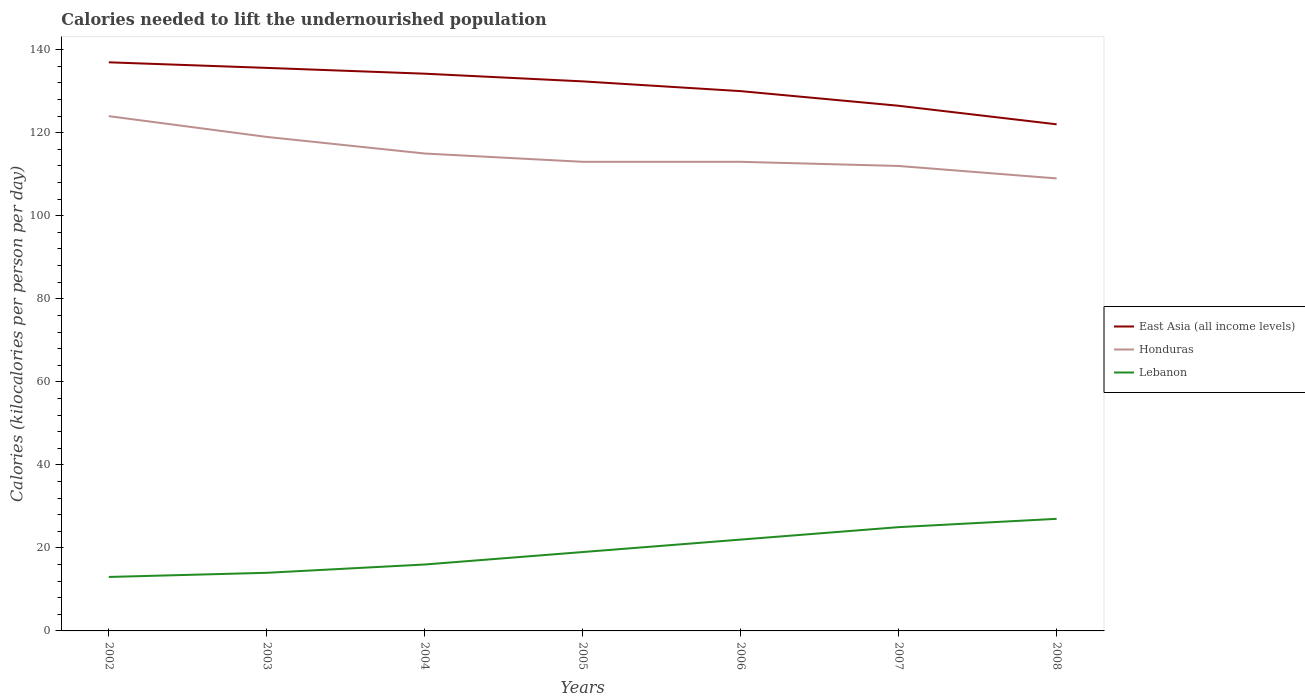Across all years, what is the maximum total calories needed to lift the undernourished population in East Asia (all income levels)?
Your answer should be compact. 122.04. In which year was the total calories needed to lift the undernourished population in Honduras maximum?
Ensure brevity in your answer.  2008. What is the total total calories needed to lift the undernourished population in Lebanon in the graph?
Your answer should be compact. -5. What is the difference between the highest and the second highest total calories needed to lift the undernourished population in Honduras?
Keep it short and to the point. 15. Is the total calories needed to lift the undernourished population in Lebanon strictly greater than the total calories needed to lift the undernourished population in East Asia (all income levels) over the years?
Your answer should be very brief. Yes. How many lines are there?
Offer a terse response. 3. Does the graph contain any zero values?
Your answer should be compact. No. Does the graph contain grids?
Keep it short and to the point. No. Where does the legend appear in the graph?
Give a very brief answer. Center right. How are the legend labels stacked?
Make the answer very short. Vertical. What is the title of the graph?
Offer a very short reply. Calories needed to lift the undernourished population. Does "Grenada" appear as one of the legend labels in the graph?
Make the answer very short. No. What is the label or title of the X-axis?
Your answer should be very brief. Years. What is the label or title of the Y-axis?
Your response must be concise. Calories (kilocalories per person per day). What is the Calories (kilocalories per person per day) in East Asia (all income levels) in 2002?
Offer a terse response. 136.97. What is the Calories (kilocalories per person per day) in Honduras in 2002?
Provide a succinct answer. 124. What is the Calories (kilocalories per person per day) in Lebanon in 2002?
Your response must be concise. 13. What is the Calories (kilocalories per person per day) of East Asia (all income levels) in 2003?
Keep it short and to the point. 135.63. What is the Calories (kilocalories per person per day) of Honduras in 2003?
Make the answer very short. 119. What is the Calories (kilocalories per person per day) of East Asia (all income levels) in 2004?
Offer a very short reply. 134.23. What is the Calories (kilocalories per person per day) of Honduras in 2004?
Your response must be concise. 115. What is the Calories (kilocalories per person per day) in Lebanon in 2004?
Make the answer very short. 16. What is the Calories (kilocalories per person per day) of East Asia (all income levels) in 2005?
Give a very brief answer. 132.38. What is the Calories (kilocalories per person per day) of Honduras in 2005?
Offer a terse response. 113. What is the Calories (kilocalories per person per day) of East Asia (all income levels) in 2006?
Ensure brevity in your answer.  130.03. What is the Calories (kilocalories per person per day) of Honduras in 2006?
Offer a terse response. 113. What is the Calories (kilocalories per person per day) in Lebanon in 2006?
Ensure brevity in your answer.  22. What is the Calories (kilocalories per person per day) in East Asia (all income levels) in 2007?
Offer a terse response. 126.5. What is the Calories (kilocalories per person per day) in Honduras in 2007?
Make the answer very short. 112. What is the Calories (kilocalories per person per day) in Lebanon in 2007?
Your answer should be compact. 25. What is the Calories (kilocalories per person per day) of East Asia (all income levels) in 2008?
Your answer should be very brief. 122.04. What is the Calories (kilocalories per person per day) in Honduras in 2008?
Your answer should be very brief. 109. Across all years, what is the maximum Calories (kilocalories per person per day) of East Asia (all income levels)?
Offer a very short reply. 136.97. Across all years, what is the maximum Calories (kilocalories per person per day) of Honduras?
Make the answer very short. 124. Across all years, what is the maximum Calories (kilocalories per person per day) of Lebanon?
Keep it short and to the point. 27. Across all years, what is the minimum Calories (kilocalories per person per day) in East Asia (all income levels)?
Your response must be concise. 122.04. Across all years, what is the minimum Calories (kilocalories per person per day) in Honduras?
Provide a succinct answer. 109. What is the total Calories (kilocalories per person per day) in East Asia (all income levels) in the graph?
Keep it short and to the point. 917.77. What is the total Calories (kilocalories per person per day) of Honduras in the graph?
Your answer should be compact. 805. What is the total Calories (kilocalories per person per day) in Lebanon in the graph?
Provide a short and direct response. 136. What is the difference between the Calories (kilocalories per person per day) in East Asia (all income levels) in 2002 and that in 2003?
Provide a succinct answer. 1.34. What is the difference between the Calories (kilocalories per person per day) of East Asia (all income levels) in 2002 and that in 2004?
Give a very brief answer. 2.74. What is the difference between the Calories (kilocalories per person per day) of East Asia (all income levels) in 2002 and that in 2005?
Your response must be concise. 4.59. What is the difference between the Calories (kilocalories per person per day) in Lebanon in 2002 and that in 2005?
Offer a terse response. -6. What is the difference between the Calories (kilocalories per person per day) of East Asia (all income levels) in 2002 and that in 2006?
Keep it short and to the point. 6.94. What is the difference between the Calories (kilocalories per person per day) of Honduras in 2002 and that in 2006?
Offer a very short reply. 11. What is the difference between the Calories (kilocalories per person per day) of East Asia (all income levels) in 2002 and that in 2007?
Your answer should be compact. 10.47. What is the difference between the Calories (kilocalories per person per day) of Honduras in 2002 and that in 2007?
Offer a very short reply. 12. What is the difference between the Calories (kilocalories per person per day) of East Asia (all income levels) in 2002 and that in 2008?
Provide a short and direct response. 14.94. What is the difference between the Calories (kilocalories per person per day) in Lebanon in 2002 and that in 2008?
Provide a short and direct response. -14. What is the difference between the Calories (kilocalories per person per day) in East Asia (all income levels) in 2003 and that in 2004?
Provide a short and direct response. 1.4. What is the difference between the Calories (kilocalories per person per day) in East Asia (all income levels) in 2003 and that in 2005?
Your answer should be very brief. 3.25. What is the difference between the Calories (kilocalories per person per day) in Honduras in 2003 and that in 2005?
Provide a succinct answer. 6. What is the difference between the Calories (kilocalories per person per day) in East Asia (all income levels) in 2003 and that in 2006?
Your answer should be compact. 5.6. What is the difference between the Calories (kilocalories per person per day) in Honduras in 2003 and that in 2006?
Provide a short and direct response. 6. What is the difference between the Calories (kilocalories per person per day) in Lebanon in 2003 and that in 2006?
Provide a short and direct response. -8. What is the difference between the Calories (kilocalories per person per day) in East Asia (all income levels) in 2003 and that in 2007?
Ensure brevity in your answer.  9.12. What is the difference between the Calories (kilocalories per person per day) in East Asia (all income levels) in 2003 and that in 2008?
Make the answer very short. 13.59. What is the difference between the Calories (kilocalories per person per day) of Lebanon in 2003 and that in 2008?
Provide a short and direct response. -13. What is the difference between the Calories (kilocalories per person per day) in East Asia (all income levels) in 2004 and that in 2005?
Offer a very short reply. 1.85. What is the difference between the Calories (kilocalories per person per day) in East Asia (all income levels) in 2004 and that in 2006?
Offer a terse response. 4.2. What is the difference between the Calories (kilocalories per person per day) of Honduras in 2004 and that in 2006?
Make the answer very short. 2. What is the difference between the Calories (kilocalories per person per day) of Lebanon in 2004 and that in 2006?
Keep it short and to the point. -6. What is the difference between the Calories (kilocalories per person per day) of East Asia (all income levels) in 2004 and that in 2007?
Provide a succinct answer. 7.73. What is the difference between the Calories (kilocalories per person per day) of East Asia (all income levels) in 2004 and that in 2008?
Ensure brevity in your answer.  12.19. What is the difference between the Calories (kilocalories per person per day) of Lebanon in 2004 and that in 2008?
Keep it short and to the point. -11. What is the difference between the Calories (kilocalories per person per day) in East Asia (all income levels) in 2005 and that in 2006?
Offer a terse response. 2.35. What is the difference between the Calories (kilocalories per person per day) of Lebanon in 2005 and that in 2006?
Provide a short and direct response. -3. What is the difference between the Calories (kilocalories per person per day) of East Asia (all income levels) in 2005 and that in 2007?
Give a very brief answer. 5.88. What is the difference between the Calories (kilocalories per person per day) of Lebanon in 2005 and that in 2007?
Your answer should be compact. -6. What is the difference between the Calories (kilocalories per person per day) of East Asia (all income levels) in 2005 and that in 2008?
Give a very brief answer. 10.34. What is the difference between the Calories (kilocalories per person per day) of Honduras in 2005 and that in 2008?
Give a very brief answer. 4. What is the difference between the Calories (kilocalories per person per day) of East Asia (all income levels) in 2006 and that in 2007?
Keep it short and to the point. 3.53. What is the difference between the Calories (kilocalories per person per day) in Lebanon in 2006 and that in 2007?
Keep it short and to the point. -3. What is the difference between the Calories (kilocalories per person per day) of East Asia (all income levels) in 2006 and that in 2008?
Provide a succinct answer. 7.99. What is the difference between the Calories (kilocalories per person per day) of Lebanon in 2006 and that in 2008?
Your response must be concise. -5. What is the difference between the Calories (kilocalories per person per day) in East Asia (all income levels) in 2007 and that in 2008?
Your answer should be very brief. 4.47. What is the difference between the Calories (kilocalories per person per day) in Lebanon in 2007 and that in 2008?
Give a very brief answer. -2. What is the difference between the Calories (kilocalories per person per day) in East Asia (all income levels) in 2002 and the Calories (kilocalories per person per day) in Honduras in 2003?
Offer a very short reply. 17.97. What is the difference between the Calories (kilocalories per person per day) of East Asia (all income levels) in 2002 and the Calories (kilocalories per person per day) of Lebanon in 2003?
Offer a very short reply. 122.97. What is the difference between the Calories (kilocalories per person per day) in Honduras in 2002 and the Calories (kilocalories per person per day) in Lebanon in 2003?
Ensure brevity in your answer.  110. What is the difference between the Calories (kilocalories per person per day) in East Asia (all income levels) in 2002 and the Calories (kilocalories per person per day) in Honduras in 2004?
Provide a short and direct response. 21.97. What is the difference between the Calories (kilocalories per person per day) in East Asia (all income levels) in 2002 and the Calories (kilocalories per person per day) in Lebanon in 2004?
Provide a short and direct response. 120.97. What is the difference between the Calories (kilocalories per person per day) of Honduras in 2002 and the Calories (kilocalories per person per day) of Lebanon in 2004?
Offer a very short reply. 108. What is the difference between the Calories (kilocalories per person per day) in East Asia (all income levels) in 2002 and the Calories (kilocalories per person per day) in Honduras in 2005?
Your response must be concise. 23.97. What is the difference between the Calories (kilocalories per person per day) of East Asia (all income levels) in 2002 and the Calories (kilocalories per person per day) of Lebanon in 2005?
Provide a short and direct response. 117.97. What is the difference between the Calories (kilocalories per person per day) of Honduras in 2002 and the Calories (kilocalories per person per day) of Lebanon in 2005?
Make the answer very short. 105. What is the difference between the Calories (kilocalories per person per day) in East Asia (all income levels) in 2002 and the Calories (kilocalories per person per day) in Honduras in 2006?
Ensure brevity in your answer.  23.97. What is the difference between the Calories (kilocalories per person per day) of East Asia (all income levels) in 2002 and the Calories (kilocalories per person per day) of Lebanon in 2006?
Offer a terse response. 114.97. What is the difference between the Calories (kilocalories per person per day) of Honduras in 2002 and the Calories (kilocalories per person per day) of Lebanon in 2006?
Your answer should be compact. 102. What is the difference between the Calories (kilocalories per person per day) in East Asia (all income levels) in 2002 and the Calories (kilocalories per person per day) in Honduras in 2007?
Offer a very short reply. 24.97. What is the difference between the Calories (kilocalories per person per day) in East Asia (all income levels) in 2002 and the Calories (kilocalories per person per day) in Lebanon in 2007?
Your answer should be very brief. 111.97. What is the difference between the Calories (kilocalories per person per day) of Honduras in 2002 and the Calories (kilocalories per person per day) of Lebanon in 2007?
Keep it short and to the point. 99. What is the difference between the Calories (kilocalories per person per day) in East Asia (all income levels) in 2002 and the Calories (kilocalories per person per day) in Honduras in 2008?
Ensure brevity in your answer.  27.97. What is the difference between the Calories (kilocalories per person per day) in East Asia (all income levels) in 2002 and the Calories (kilocalories per person per day) in Lebanon in 2008?
Keep it short and to the point. 109.97. What is the difference between the Calories (kilocalories per person per day) of Honduras in 2002 and the Calories (kilocalories per person per day) of Lebanon in 2008?
Offer a very short reply. 97. What is the difference between the Calories (kilocalories per person per day) in East Asia (all income levels) in 2003 and the Calories (kilocalories per person per day) in Honduras in 2004?
Your answer should be compact. 20.63. What is the difference between the Calories (kilocalories per person per day) of East Asia (all income levels) in 2003 and the Calories (kilocalories per person per day) of Lebanon in 2004?
Your answer should be compact. 119.63. What is the difference between the Calories (kilocalories per person per day) in Honduras in 2003 and the Calories (kilocalories per person per day) in Lebanon in 2004?
Make the answer very short. 103. What is the difference between the Calories (kilocalories per person per day) in East Asia (all income levels) in 2003 and the Calories (kilocalories per person per day) in Honduras in 2005?
Provide a short and direct response. 22.63. What is the difference between the Calories (kilocalories per person per day) in East Asia (all income levels) in 2003 and the Calories (kilocalories per person per day) in Lebanon in 2005?
Keep it short and to the point. 116.63. What is the difference between the Calories (kilocalories per person per day) in East Asia (all income levels) in 2003 and the Calories (kilocalories per person per day) in Honduras in 2006?
Your answer should be very brief. 22.63. What is the difference between the Calories (kilocalories per person per day) in East Asia (all income levels) in 2003 and the Calories (kilocalories per person per day) in Lebanon in 2006?
Provide a short and direct response. 113.63. What is the difference between the Calories (kilocalories per person per day) of Honduras in 2003 and the Calories (kilocalories per person per day) of Lebanon in 2006?
Your answer should be compact. 97. What is the difference between the Calories (kilocalories per person per day) in East Asia (all income levels) in 2003 and the Calories (kilocalories per person per day) in Honduras in 2007?
Make the answer very short. 23.63. What is the difference between the Calories (kilocalories per person per day) in East Asia (all income levels) in 2003 and the Calories (kilocalories per person per day) in Lebanon in 2007?
Make the answer very short. 110.63. What is the difference between the Calories (kilocalories per person per day) in Honduras in 2003 and the Calories (kilocalories per person per day) in Lebanon in 2007?
Your answer should be compact. 94. What is the difference between the Calories (kilocalories per person per day) in East Asia (all income levels) in 2003 and the Calories (kilocalories per person per day) in Honduras in 2008?
Offer a very short reply. 26.63. What is the difference between the Calories (kilocalories per person per day) in East Asia (all income levels) in 2003 and the Calories (kilocalories per person per day) in Lebanon in 2008?
Give a very brief answer. 108.63. What is the difference between the Calories (kilocalories per person per day) in Honduras in 2003 and the Calories (kilocalories per person per day) in Lebanon in 2008?
Make the answer very short. 92. What is the difference between the Calories (kilocalories per person per day) in East Asia (all income levels) in 2004 and the Calories (kilocalories per person per day) in Honduras in 2005?
Give a very brief answer. 21.23. What is the difference between the Calories (kilocalories per person per day) of East Asia (all income levels) in 2004 and the Calories (kilocalories per person per day) of Lebanon in 2005?
Offer a very short reply. 115.23. What is the difference between the Calories (kilocalories per person per day) in Honduras in 2004 and the Calories (kilocalories per person per day) in Lebanon in 2005?
Your answer should be very brief. 96. What is the difference between the Calories (kilocalories per person per day) in East Asia (all income levels) in 2004 and the Calories (kilocalories per person per day) in Honduras in 2006?
Ensure brevity in your answer.  21.23. What is the difference between the Calories (kilocalories per person per day) in East Asia (all income levels) in 2004 and the Calories (kilocalories per person per day) in Lebanon in 2006?
Give a very brief answer. 112.23. What is the difference between the Calories (kilocalories per person per day) in Honduras in 2004 and the Calories (kilocalories per person per day) in Lebanon in 2006?
Ensure brevity in your answer.  93. What is the difference between the Calories (kilocalories per person per day) in East Asia (all income levels) in 2004 and the Calories (kilocalories per person per day) in Honduras in 2007?
Provide a succinct answer. 22.23. What is the difference between the Calories (kilocalories per person per day) of East Asia (all income levels) in 2004 and the Calories (kilocalories per person per day) of Lebanon in 2007?
Your answer should be very brief. 109.23. What is the difference between the Calories (kilocalories per person per day) of Honduras in 2004 and the Calories (kilocalories per person per day) of Lebanon in 2007?
Offer a terse response. 90. What is the difference between the Calories (kilocalories per person per day) in East Asia (all income levels) in 2004 and the Calories (kilocalories per person per day) in Honduras in 2008?
Offer a very short reply. 25.23. What is the difference between the Calories (kilocalories per person per day) of East Asia (all income levels) in 2004 and the Calories (kilocalories per person per day) of Lebanon in 2008?
Provide a short and direct response. 107.23. What is the difference between the Calories (kilocalories per person per day) in East Asia (all income levels) in 2005 and the Calories (kilocalories per person per day) in Honduras in 2006?
Ensure brevity in your answer.  19.38. What is the difference between the Calories (kilocalories per person per day) of East Asia (all income levels) in 2005 and the Calories (kilocalories per person per day) of Lebanon in 2006?
Provide a succinct answer. 110.38. What is the difference between the Calories (kilocalories per person per day) of Honduras in 2005 and the Calories (kilocalories per person per day) of Lebanon in 2006?
Your response must be concise. 91. What is the difference between the Calories (kilocalories per person per day) in East Asia (all income levels) in 2005 and the Calories (kilocalories per person per day) in Honduras in 2007?
Provide a short and direct response. 20.38. What is the difference between the Calories (kilocalories per person per day) in East Asia (all income levels) in 2005 and the Calories (kilocalories per person per day) in Lebanon in 2007?
Provide a succinct answer. 107.38. What is the difference between the Calories (kilocalories per person per day) of Honduras in 2005 and the Calories (kilocalories per person per day) of Lebanon in 2007?
Your answer should be very brief. 88. What is the difference between the Calories (kilocalories per person per day) of East Asia (all income levels) in 2005 and the Calories (kilocalories per person per day) of Honduras in 2008?
Your answer should be very brief. 23.38. What is the difference between the Calories (kilocalories per person per day) of East Asia (all income levels) in 2005 and the Calories (kilocalories per person per day) of Lebanon in 2008?
Offer a terse response. 105.38. What is the difference between the Calories (kilocalories per person per day) of Honduras in 2005 and the Calories (kilocalories per person per day) of Lebanon in 2008?
Ensure brevity in your answer.  86. What is the difference between the Calories (kilocalories per person per day) in East Asia (all income levels) in 2006 and the Calories (kilocalories per person per day) in Honduras in 2007?
Your answer should be compact. 18.03. What is the difference between the Calories (kilocalories per person per day) of East Asia (all income levels) in 2006 and the Calories (kilocalories per person per day) of Lebanon in 2007?
Offer a very short reply. 105.03. What is the difference between the Calories (kilocalories per person per day) in East Asia (all income levels) in 2006 and the Calories (kilocalories per person per day) in Honduras in 2008?
Your answer should be very brief. 21.03. What is the difference between the Calories (kilocalories per person per day) in East Asia (all income levels) in 2006 and the Calories (kilocalories per person per day) in Lebanon in 2008?
Keep it short and to the point. 103.03. What is the difference between the Calories (kilocalories per person per day) in East Asia (all income levels) in 2007 and the Calories (kilocalories per person per day) in Honduras in 2008?
Offer a very short reply. 17.5. What is the difference between the Calories (kilocalories per person per day) in East Asia (all income levels) in 2007 and the Calories (kilocalories per person per day) in Lebanon in 2008?
Provide a short and direct response. 99.5. What is the difference between the Calories (kilocalories per person per day) of Honduras in 2007 and the Calories (kilocalories per person per day) of Lebanon in 2008?
Keep it short and to the point. 85. What is the average Calories (kilocalories per person per day) of East Asia (all income levels) per year?
Offer a very short reply. 131.11. What is the average Calories (kilocalories per person per day) of Honduras per year?
Offer a terse response. 115. What is the average Calories (kilocalories per person per day) of Lebanon per year?
Give a very brief answer. 19.43. In the year 2002, what is the difference between the Calories (kilocalories per person per day) in East Asia (all income levels) and Calories (kilocalories per person per day) in Honduras?
Make the answer very short. 12.97. In the year 2002, what is the difference between the Calories (kilocalories per person per day) of East Asia (all income levels) and Calories (kilocalories per person per day) of Lebanon?
Your answer should be very brief. 123.97. In the year 2002, what is the difference between the Calories (kilocalories per person per day) in Honduras and Calories (kilocalories per person per day) in Lebanon?
Ensure brevity in your answer.  111. In the year 2003, what is the difference between the Calories (kilocalories per person per day) of East Asia (all income levels) and Calories (kilocalories per person per day) of Honduras?
Provide a succinct answer. 16.63. In the year 2003, what is the difference between the Calories (kilocalories per person per day) of East Asia (all income levels) and Calories (kilocalories per person per day) of Lebanon?
Your answer should be very brief. 121.63. In the year 2003, what is the difference between the Calories (kilocalories per person per day) of Honduras and Calories (kilocalories per person per day) of Lebanon?
Provide a succinct answer. 105. In the year 2004, what is the difference between the Calories (kilocalories per person per day) of East Asia (all income levels) and Calories (kilocalories per person per day) of Honduras?
Your answer should be very brief. 19.23. In the year 2004, what is the difference between the Calories (kilocalories per person per day) of East Asia (all income levels) and Calories (kilocalories per person per day) of Lebanon?
Offer a terse response. 118.23. In the year 2004, what is the difference between the Calories (kilocalories per person per day) of Honduras and Calories (kilocalories per person per day) of Lebanon?
Make the answer very short. 99. In the year 2005, what is the difference between the Calories (kilocalories per person per day) in East Asia (all income levels) and Calories (kilocalories per person per day) in Honduras?
Provide a short and direct response. 19.38. In the year 2005, what is the difference between the Calories (kilocalories per person per day) in East Asia (all income levels) and Calories (kilocalories per person per day) in Lebanon?
Give a very brief answer. 113.38. In the year 2005, what is the difference between the Calories (kilocalories per person per day) in Honduras and Calories (kilocalories per person per day) in Lebanon?
Provide a short and direct response. 94. In the year 2006, what is the difference between the Calories (kilocalories per person per day) in East Asia (all income levels) and Calories (kilocalories per person per day) in Honduras?
Your response must be concise. 17.03. In the year 2006, what is the difference between the Calories (kilocalories per person per day) in East Asia (all income levels) and Calories (kilocalories per person per day) in Lebanon?
Ensure brevity in your answer.  108.03. In the year 2006, what is the difference between the Calories (kilocalories per person per day) in Honduras and Calories (kilocalories per person per day) in Lebanon?
Give a very brief answer. 91. In the year 2007, what is the difference between the Calories (kilocalories per person per day) in East Asia (all income levels) and Calories (kilocalories per person per day) in Honduras?
Keep it short and to the point. 14.5. In the year 2007, what is the difference between the Calories (kilocalories per person per day) of East Asia (all income levels) and Calories (kilocalories per person per day) of Lebanon?
Your answer should be very brief. 101.5. In the year 2008, what is the difference between the Calories (kilocalories per person per day) in East Asia (all income levels) and Calories (kilocalories per person per day) in Honduras?
Ensure brevity in your answer.  13.04. In the year 2008, what is the difference between the Calories (kilocalories per person per day) in East Asia (all income levels) and Calories (kilocalories per person per day) in Lebanon?
Offer a very short reply. 95.04. What is the ratio of the Calories (kilocalories per person per day) of East Asia (all income levels) in 2002 to that in 2003?
Your answer should be very brief. 1.01. What is the ratio of the Calories (kilocalories per person per day) in Honduras in 2002 to that in 2003?
Your response must be concise. 1.04. What is the ratio of the Calories (kilocalories per person per day) in Lebanon in 2002 to that in 2003?
Provide a succinct answer. 0.93. What is the ratio of the Calories (kilocalories per person per day) in East Asia (all income levels) in 2002 to that in 2004?
Your response must be concise. 1.02. What is the ratio of the Calories (kilocalories per person per day) of Honduras in 2002 to that in 2004?
Ensure brevity in your answer.  1.08. What is the ratio of the Calories (kilocalories per person per day) in Lebanon in 2002 to that in 2004?
Provide a succinct answer. 0.81. What is the ratio of the Calories (kilocalories per person per day) of East Asia (all income levels) in 2002 to that in 2005?
Your answer should be compact. 1.03. What is the ratio of the Calories (kilocalories per person per day) in Honduras in 2002 to that in 2005?
Keep it short and to the point. 1.1. What is the ratio of the Calories (kilocalories per person per day) in Lebanon in 2002 to that in 2005?
Your answer should be very brief. 0.68. What is the ratio of the Calories (kilocalories per person per day) of East Asia (all income levels) in 2002 to that in 2006?
Offer a very short reply. 1.05. What is the ratio of the Calories (kilocalories per person per day) in Honduras in 2002 to that in 2006?
Keep it short and to the point. 1.1. What is the ratio of the Calories (kilocalories per person per day) in Lebanon in 2002 to that in 2006?
Your answer should be very brief. 0.59. What is the ratio of the Calories (kilocalories per person per day) in East Asia (all income levels) in 2002 to that in 2007?
Provide a succinct answer. 1.08. What is the ratio of the Calories (kilocalories per person per day) in Honduras in 2002 to that in 2007?
Your response must be concise. 1.11. What is the ratio of the Calories (kilocalories per person per day) of Lebanon in 2002 to that in 2007?
Offer a very short reply. 0.52. What is the ratio of the Calories (kilocalories per person per day) in East Asia (all income levels) in 2002 to that in 2008?
Your answer should be compact. 1.12. What is the ratio of the Calories (kilocalories per person per day) of Honduras in 2002 to that in 2008?
Keep it short and to the point. 1.14. What is the ratio of the Calories (kilocalories per person per day) of Lebanon in 2002 to that in 2008?
Offer a very short reply. 0.48. What is the ratio of the Calories (kilocalories per person per day) of East Asia (all income levels) in 2003 to that in 2004?
Your answer should be very brief. 1.01. What is the ratio of the Calories (kilocalories per person per day) of Honduras in 2003 to that in 2004?
Your response must be concise. 1.03. What is the ratio of the Calories (kilocalories per person per day) in Lebanon in 2003 to that in 2004?
Offer a very short reply. 0.88. What is the ratio of the Calories (kilocalories per person per day) in East Asia (all income levels) in 2003 to that in 2005?
Offer a terse response. 1.02. What is the ratio of the Calories (kilocalories per person per day) of Honduras in 2003 to that in 2005?
Offer a very short reply. 1.05. What is the ratio of the Calories (kilocalories per person per day) of Lebanon in 2003 to that in 2005?
Your response must be concise. 0.74. What is the ratio of the Calories (kilocalories per person per day) of East Asia (all income levels) in 2003 to that in 2006?
Your answer should be compact. 1.04. What is the ratio of the Calories (kilocalories per person per day) of Honduras in 2003 to that in 2006?
Provide a short and direct response. 1.05. What is the ratio of the Calories (kilocalories per person per day) in Lebanon in 2003 to that in 2006?
Your answer should be compact. 0.64. What is the ratio of the Calories (kilocalories per person per day) in East Asia (all income levels) in 2003 to that in 2007?
Give a very brief answer. 1.07. What is the ratio of the Calories (kilocalories per person per day) of Lebanon in 2003 to that in 2007?
Offer a very short reply. 0.56. What is the ratio of the Calories (kilocalories per person per day) of East Asia (all income levels) in 2003 to that in 2008?
Give a very brief answer. 1.11. What is the ratio of the Calories (kilocalories per person per day) in Honduras in 2003 to that in 2008?
Offer a very short reply. 1.09. What is the ratio of the Calories (kilocalories per person per day) of Lebanon in 2003 to that in 2008?
Your answer should be very brief. 0.52. What is the ratio of the Calories (kilocalories per person per day) of Honduras in 2004 to that in 2005?
Offer a very short reply. 1.02. What is the ratio of the Calories (kilocalories per person per day) in Lebanon in 2004 to that in 2005?
Offer a very short reply. 0.84. What is the ratio of the Calories (kilocalories per person per day) of East Asia (all income levels) in 2004 to that in 2006?
Provide a succinct answer. 1.03. What is the ratio of the Calories (kilocalories per person per day) in Honduras in 2004 to that in 2006?
Give a very brief answer. 1.02. What is the ratio of the Calories (kilocalories per person per day) in Lebanon in 2004 to that in 2006?
Ensure brevity in your answer.  0.73. What is the ratio of the Calories (kilocalories per person per day) in East Asia (all income levels) in 2004 to that in 2007?
Your response must be concise. 1.06. What is the ratio of the Calories (kilocalories per person per day) of Honduras in 2004 to that in 2007?
Ensure brevity in your answer.  1.03. What is the ratio of the Calories (kilocalories per person per day) of Lebanon in 2004 to that in 2007?
Give a very brief answer. 0.64. What is the ratio of the Calories (kilocalories per person per day) in East Asia (all income levels) in 2004 to that in 2008?
Give a very brief answer. 1.1. What is the ratio of the Calories (kilocalories per person per day) in Honduras in 2004 to that in 2008?
Make the answer very short. 1.05. What is the ratio of the Calories (kilocalories per person per day) in Lebanon in 2004 to that in 2008?
Your response must be concise. 0.59. What is the ratio of the Calories (kilocalories per person per day) in East Asia (all income levels) in 2005 to that in 2006?
Your response must be concise. 1.02. What is the ratio of the Calories (kilocalories per person per day) of Honduras in 2005 to that in 2006?
Provide a succinct answer. 1. What is the ratio of the Calories (kilocalories per person per day) in Lebanon in 2005 to that in 2006?
Your answer should be very brief. 0.86. What is the ratio of the Calories (kilocalories per person per day) in East Asia (all income levels) in 2005 to that in 2007?
Your answer should be very brief. 1.05. What is the ratio of the Calories (kilocalories per person per day) in Honduras in 2005 to that in 2007?
Give a very brief answer. 1.01. What is the ratio of the Calories (kilocalories per person per day) in Lebanon in 2005 to that in 2007?
Your answer should be compact. 0.76. What is the ratio of the Calories (kilocalories per person per day) of East Asia (all income levels) in 2005 to that in 2008?
Give a very brief answer. 1.08. What is the ratio of the Calories (kilocalories per person per day) of Honduras in 2005 to that in 2008?
Provide a succinct answer. 1.04. What is the ratio of the Calories (kilocalories per person per day) in Lebanon in 2005 to that in 2008?
Provide a short and direct response. 0.7. What is the ratio of the Calories (kilocalories per person per day) of East Asia (all income levels) in 2006 to that in 2007?
Offer a very short reply. 1.03. What is the ratio of the Calories (kilocalories per person per day) in Honduras in 2006 to that in 2007?
Offer a terse response. 1.01. What is the ratio of the Calories (kilocalories per person per day) in Lebanon in 2006 to that in 2007?
Offer a very short reply. 0.88. What is the ratio of the Calories (kilocalories per person per day) of East Asia (all income levels) in 2006 to that in 2008?
Your response must be concise. 1.07. What is the ratio of the Calories (kilocalories per person per day) of Honduras in 2006 to that in 2008?
Keep it short and to the point. 1.04. What is the ratio of the Calories (kilocalories per person per day) in Lebanon in 2006 to that in 2008?
Offer a very short reply. 0.81. What is the ratio of the Calories (kilocalories per person per day) in East Asia (all income levels) in 2007 to that in 2008?
Your response must be concise. 1.04. What is the ratio of the Calories (kilocalories per person per day) of Honduras in 2007 to that in 2008?
Ensure brevity in your answer.  1.03. What is the ratio of the Calories (kilocalories per person per day) of Lebanon in 2007 to that in 2008?
Ensure brevity in your answer.  0.93. What is the difference between the highest and the second highest Calories (kilocalories per person per day) of East Asia (all income levels)?
Provide a short and direct response. 1.34. What is the difference between the highest and the second highest Calories (kilocalories per person per day) of Honduras?
Your answer should be compact. 5. What is the difference between the highest and the second highest Calories (kilocalories per person per day) in Lebanon?
Ensure brevity in your answer.  2. What is the difference between the highest and the lowest Calories (kilocalories per person per day) of East Asia (all income levels)?
Your answer should be compact. 14.94. What is the difference between the highest and the lowest Calories (kilocalories per person per day) in Honduras?
Your answer should be very brief. 15. What is the difference between the highest and the lowest Calories (kilocalories per person per day) of Lebanon?
Offer a terse response. 14. 